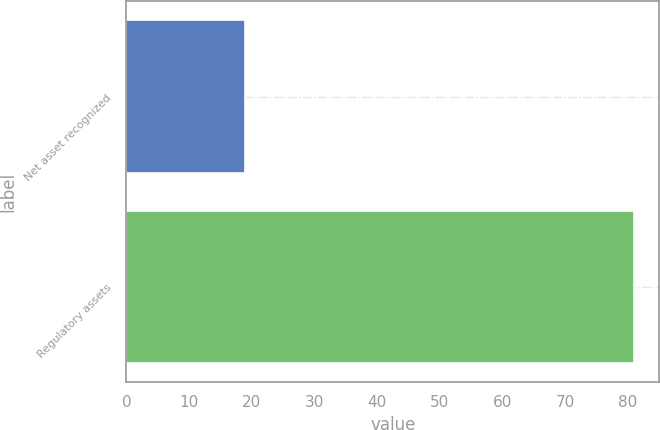Convert chart. <chart><loc_0><loc_0><loc_500><loc_500><bar_chart><fcel>Net asset recognized<fcel>Regulatory assets<nl><fcel>19<fcel>81<nl></chart> 